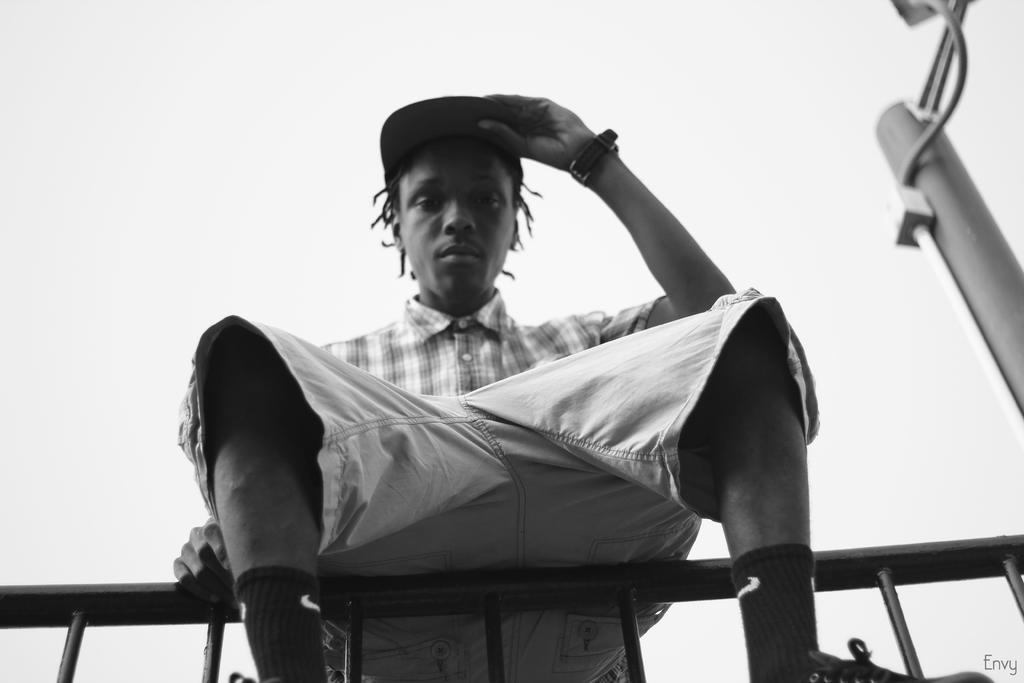What is the person in the image doing? The person is sitting on a metal fence in the image. What can be seen behind the person? There is a pole visible behind the person. What type of owl can be seen perched on the person's shoulder in the image? There is no owl present in the image; the person is sitting on a metal fence with a pole visible behind them. 